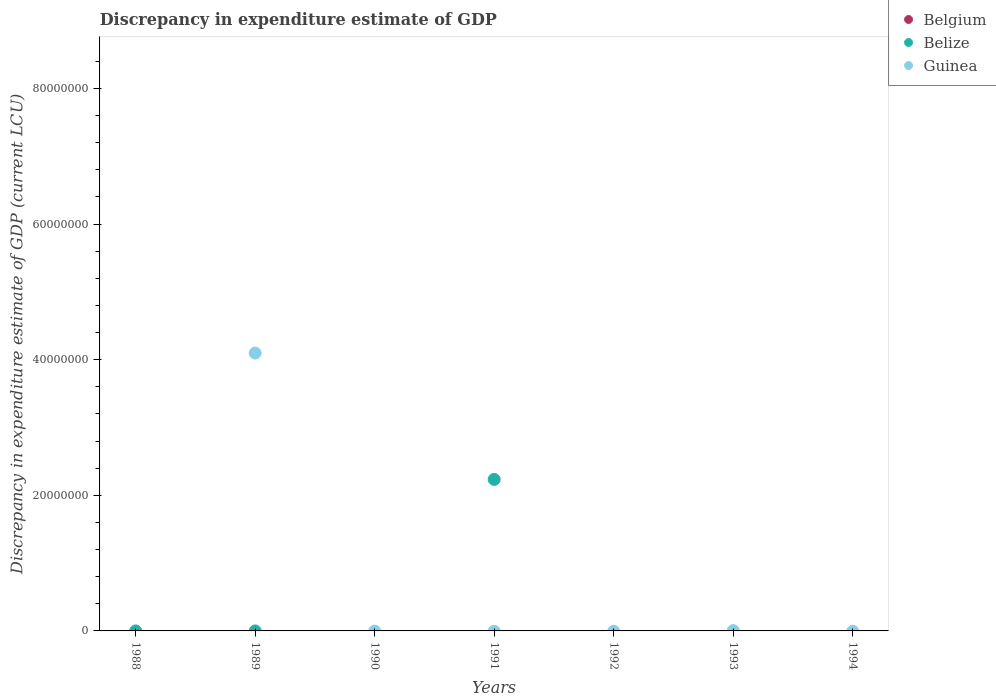Across all years, what is the maximum discrepancy in expenditure estimate of GDP in Guinea?
Provide a succinct answer. 4.10e+07. Across all years, what is the minimum discrepancy in expenditure estimate of GDP in Guinea?
Offer a very short reply. 0. What is the total discrepancy in expenditure estimate of GDP in Belgium in the graph?
Offer a very short reply. 0. What is the difference between the discrepancy in expenditure estimate of GDP in Guinea in 1988 and the discrepancy in expenditure estimate of GDP in Belgium in 1994?
Provide a succinct answer. 0. In the year 1989, what is the difference between the discrepancy in expenditure estimate of GDP in Belize and discrepancy in expenditure estimate of GDP in Guinea?
Offer a terse response. -4.10e+07. What is the difference between the highest and the lowest discrepancy in expenditure estimate of GDP in Guinea?
Your response must be concise. 4.10e+07. How many dotlines are there?
Your answer should be very brief. 2. How many years are there in the graph?
Give a very brief answer. 7. What is the difference between two consecutive major ticks on the Y-axis?
Your answer should be compact. 2.00e+07. Does the graph contain any zero values?
Offer a very short reply. Yes. Does the graph contain grids?
Make the answer very short. No. What is the title of the graph?
Your response must be concise. Discrepancy in expenditure estimate of GDP. What is the label or title of the X-axis?
Give a very brief answer. Years. What is the label or title of the Y-axis?
Give a very brief answer. Discrepancy in expenditure estimate of GDP (current LCU). What is the Discrepancy in expenditure estimate of GDP (current LCU) of Belgium in 1988?
Give a very brief answer. 0. What is the Discrepancy in expenditure estimate of GDP (current LCU) in Belize in 1988?
Give a very brief answer. 0. What is the Discrepancy in expenditure estimate of GDP (current LCU) in Belize in 1989?
Ensure brevity in your answer.  6e-8. What is the Discrepancy in expenditure estimate of GDP (current LCU) of Guinea in 1989?
Give a very brief answer. 4.10e+07. What is the Discrepancy in expenditure estimate of GDP (current LCU) in Guinea in 1990?
Provide a succinct answer. 0. What is the Discrepancy in expenditure estimate of GDP (current LCU) in Belgium in 1991?
Give a very brief answer. 0. What is the Discrepancy in expenditure estimate of GDP (current LCU) of Belize in 1991?
Your answer should be compact. 2.23e+07. What is the Discrepancy in expenditure estimate of GDP (current LCU) of Belize in 1992?
Offer a terse response. 0. What is the Discrepancy in expenditure estimate of GDP (current LCU) of Guinea in 1992?
Your answer should be compact. 0. What is the Discrepancy in expenditure estimate of GDP (current LCU) in Belgium in 1993?
Provide a short and direct response. 0. What is the Discrepancy in expenditure estimate of GDP (current LCU) of Belize in 1993?
Offer a terse response. 0. What is the Discrepancy in expenditure estimate of GDP (current LCU) of Guinea in 1993?
Keep it short and to the point. 3.94e+04. What is the Discrepancy in expenditure estimate of GDP (current LCU) in Belgium in 1994?
Keep it short and to the point. 0. What is the Discrepancy in expenditure estimate of GDP (current LCU) in Guinea in 1994?
Your answer should be very brief. 0. Across all years, what is the maximum Discrepancy in expenditure estimate of GDP (current LCU) of Belize?
Provide a short and direct response. 2.23e+07. Across all years, what is the maximum Discrepancy in expenditure estimate of GDP (current LCU) of Guinea?
Your answer should be compact. 4.10e+07. What is the total Discrepancy in expenditure estimate of GDP (current LCU) in Belize in the graph?
Keep it short and to the point. 2.23e+07. What is the total Discrepancy in expenditure estimate of GDP (current LCU) of Guinea in the graph?
Make the answer very short. 4.10e+07. What is the difference between the Discrepancy in expenditure estimate of GDP (current LCU) in Belize in 1989 and that in 1991?
Offer a very short reply. -2.23e+07. What is the difference between the Discrepancy in expenditure estimate of GDP (current LCU) of Guinea in 1989 and that in 1993?
Keep it short and to the point. 4.09e+07. What is the difference between the Discrepancy in expenditure estimate of GDP (current LCU) of Belize in 1989 and the Discrepancy in expenditure estimate of GDP (current LCU) of Guinea in 1993?
Your answer should be compact. -3.94e+04. What is the difference between the Discrepancy in expenditure estimate of GDP (current LCU) in Belize in 1991 and the Discrepancy in expenditure estimate of GDP (current LCU) in Guinea in 1993?
Your response must be concise. 2.23e+07. What is the average Discrepancy in expenditure estimate of GDP (current LCU) of Belgium per year?
Your response must be concise. 0. What is the average Discrepancy in expenditure estimate of GDP (current LCU) in Belize per year?
Ensure brevity in your answer.  3.19e+06. What is the average Discrepancy in expenditure estimate of GDP (current LCU) in Guinea per year?
Your answer should be compact. 5.86e+06. In the year 1989, what is the difference between the Discrepancy in expenditure estimate of GDP (current LCU) in Belize and Discrepancy in expenditure estimate of GDP (current LCU) in Guinea?
Make the answer very short. -4.10e+07. What is the ratio of the Discrepancy in expenditure estimate of GDP (current LCU) of Guinea in 1989 to that in 1993?
Make the answer very short. 1039.95. What is the difference between the highest and the lowest Discrepancy in expenditure estimate of GDP (current LCU) of Belize?
Keep it short and to the point. 2.23e+07. What is the difference between the highest and the lowest Discrepancy in expenditure estimate of GDP (current LCU) in Guinea?
Offer a very short reply. 4.10e+07. 